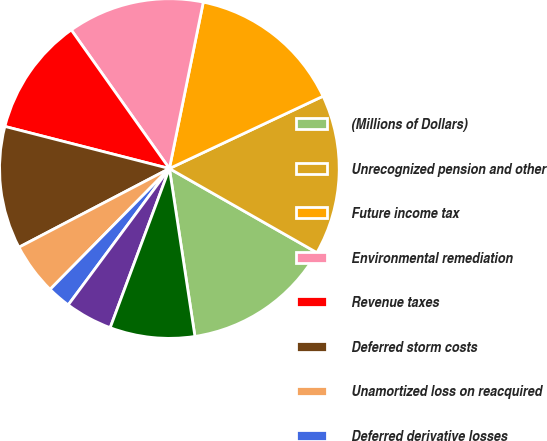Convert chart. <chart><loc_0><loc_0><loc_500><loc_500><pie_chart><fcel>(Millions of Dollars)<fcel>Unrecognized pension and other<fcel>Future income tax<fcel>Environmental remediation<fcel>Revenue taxes<fcel>Deferred storm costs<fcel>Unamortized loss on reacquired<fcel>Deferred derivative losses<fcel>Pension and other<fcel>Surcharge for New York State<nl><fcel>14.35%<fcel>15.25%<fcel>14.8%<fcel>13.0%<fcel>11.21%<fcel>11.66%<fcel>4.93%<fcel>2.24%<fcel>4.49%<fcel>8.07%<nl></chart> 